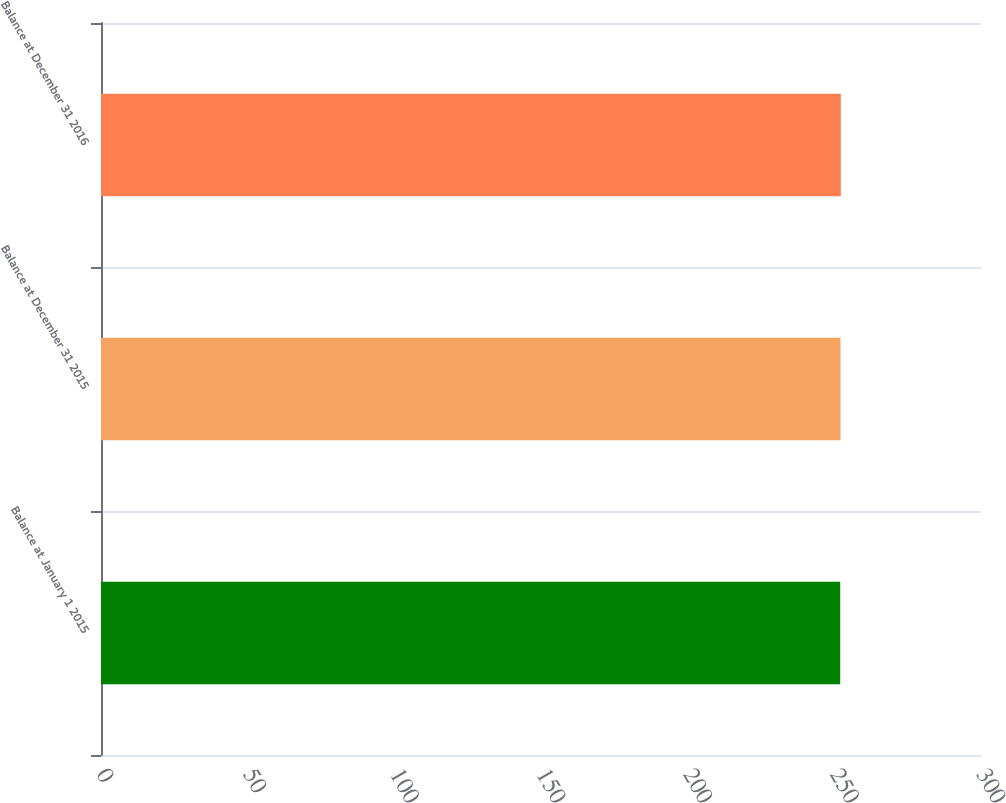Convert chart to OTSL. <chart><loc_0><loc_0><loc_500><loc_500><bar_chart><fcel>Balance at January 1 2015<fcel>Balance at December 31 2015<fcel>Balance at December 31 2016<nl><fcel>252<fcel>252.1<fcel>252.2<nl></chart> 